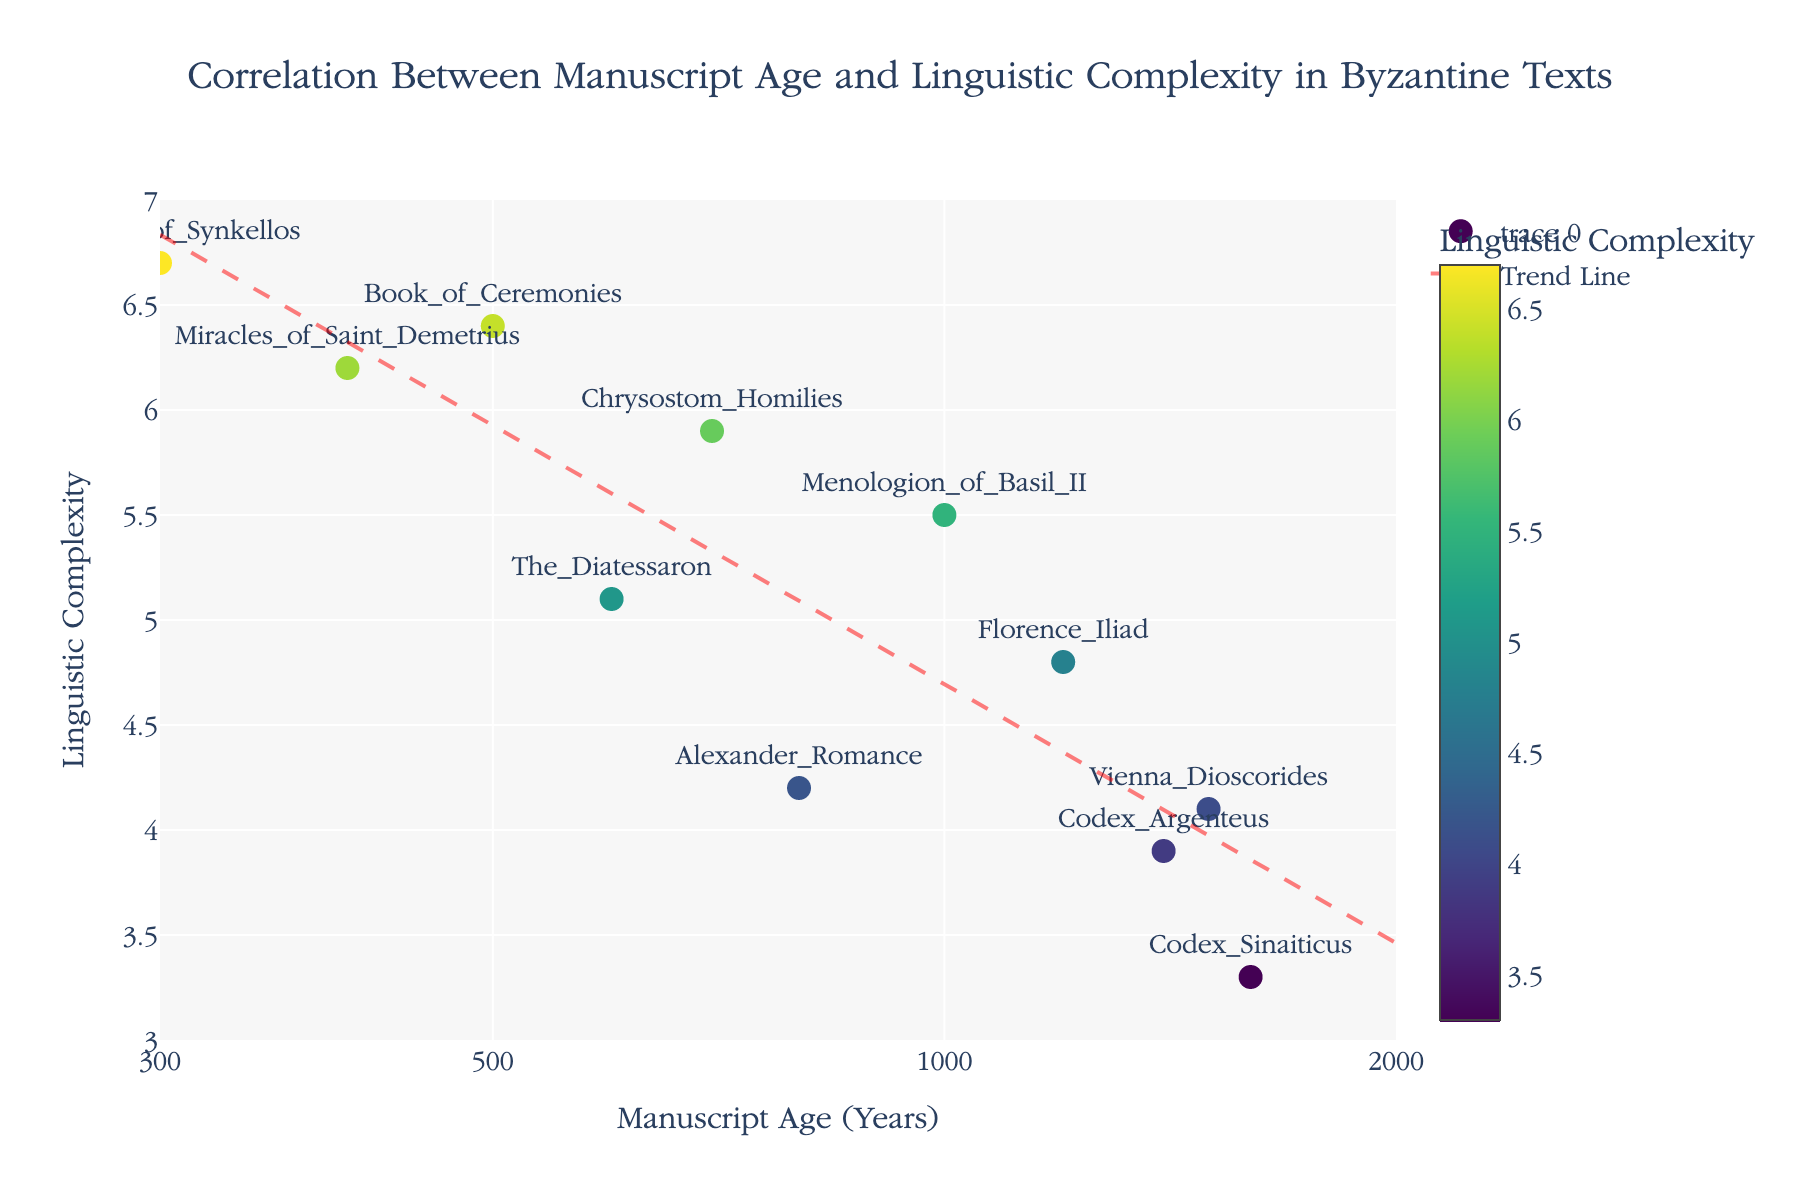How many data points are shown in the scatter plot? By counting the markers on the scatter plot, we can see each one represents a manuscript. There are a total of 11 data points shown.
Answer: 11 What is the title of the scatter plot? The title is displayed prominently at the top of the scatter plot. It reads "Correlation Between Manuscript Age and Linguistic Complexity in Byzantine Texts".
Answer: Correlation Between Manuscript Age and Linguistic Complexity in Byzantine Texts Which manuscript has the highest linguistic complexity? By looking at the y-axis and the marker texts, we find that "Chronicle_of_Synkellos" has the highest y-value at 6.7.
Answer: Chronicle_of_Synkellos What is the age range shown on the x-axis? The x-axis is a log scale ranging from approximately 300 years to 2000 years. This is indicated by the tick labels and axis title.
Answer: 300 to 2000 years Does the plot include a trend line? What color is it? Upon inspecting the plot, we see that there is a dashed trend line, which is red in color.
Answer: Yes, red What is the y-value for the "Alexander_Romance" manuscript? By hovering over or looking at the marker labeled "Alexander_Romance," we see that the y-value, representing linguistic complexity, is 4.2.
Answer: 4.2 On a log scale, which is younger: the "Menologion_of_Basil_II" or the "Florence_Iliad"? The "Menologion_of_Basil_II" has an age of 1000 years, while the "Florence_Iliad" has an age of 1200 years. Since the x-axis is a log scale, smaller numbers to the left represent younger manuscripts. Therefore, "Menologion_of_Basil_II" is younger.
Answer: Menologion_of_Basil_II Does older manuscript age correlate with higher or lower linguistic complexity according to the trend line? By observing the direction of the trend line, which slopes upward from left to right on a log scale, it indicates that older manuscripts tend to have higher linguistic complexity.
Answer: Higher What is the trend in linguistic complexity as manuscript age increases from 300 to 2000 years? The trend line in the scatter plot shows an upward slope, suggesting that linguistic complexity increases as manuscript age increases over this range.
Answer: Increases Which manuscript has an age closest to 700 years, and what is its linguistic complexity? Inspecting the markers, the "Chrysostom_Homilies" manuscript has an age of 700 years and a linguistic complexity of 5.9.
Answer: Chrysostom_Homilies, 5.9 